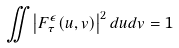<formula> <loc_0><loc_0><loc_500><loc_500>\iint \left | F _ { \tau } ^ { \epsilon } ( u , v ) \right | ^ { 2 } d u d v = 1</formula> 